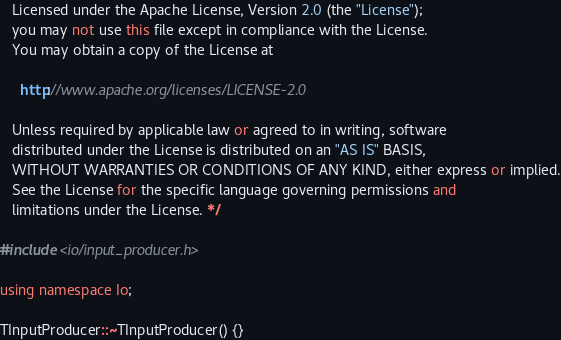Convert code to text. <code><loc_0><loc_0><loc_500><loc_500><_C++_>   Licensed under the Apache License, Version 2.0 (the "License");
   you may not use this file except in compliance with the License.
   You may obtain a copy of the License at
   
     http://www.apache.org/licenses/LICENSE-2.0
   
   Unless required by applicable law or agreed to in writing, software
   distributed under the License is distributed on an "AS IS" BASIS,
   WITHOUT WARRANTIES OR CONDITIONS OF ANY KIND, either express or implied.
   See the License for the specific language governing permissions and
   limitations under the License. */

#include <io/input_producer.h>

using namespace Io;

TInputProducer::~TInputProducer() {}

</code> 